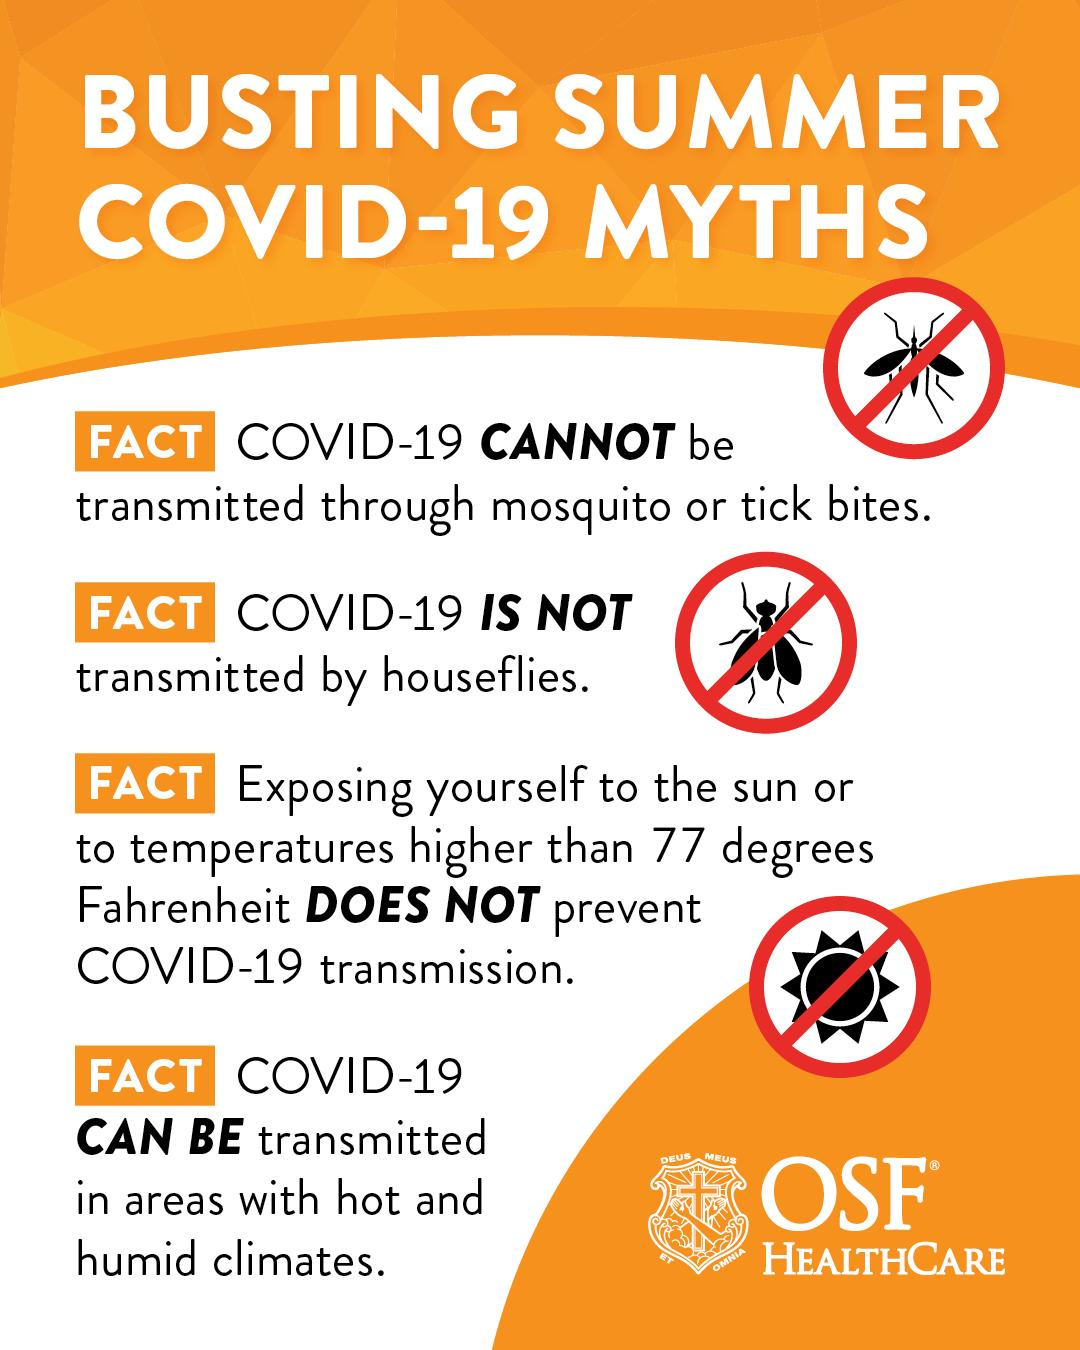Mention a couple of crucial points in this snapshot. The infographic depicts the presence of mosquitoes and houseflies among insects. It is estimated that a total of three insects are mentioned in this text. 